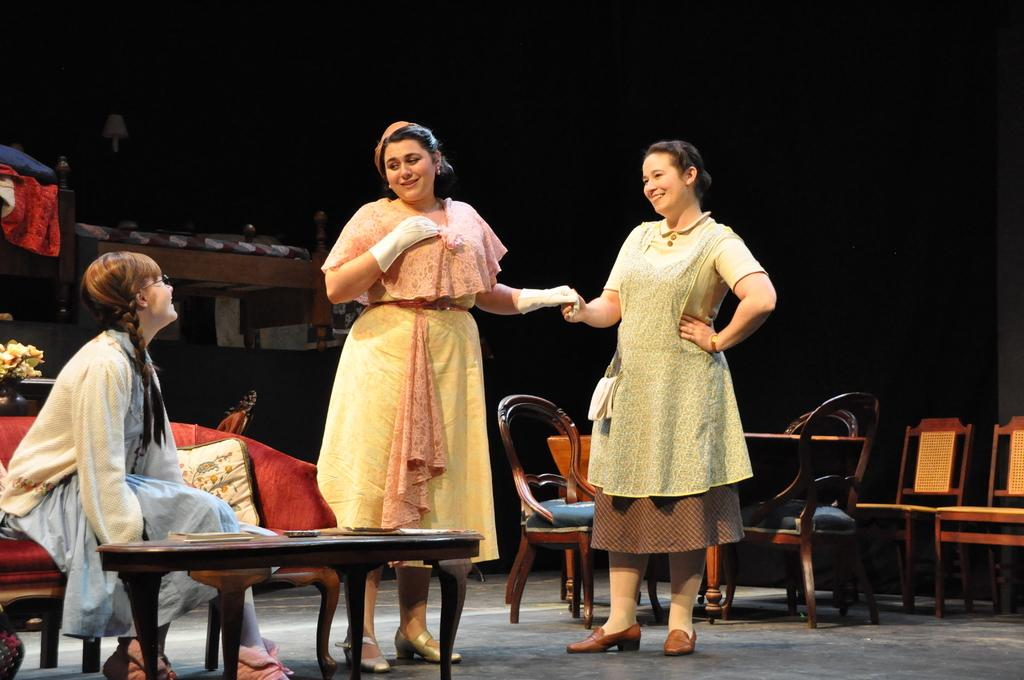What is the person in the image doing? The person is sitting on a sofa in the image. Where is the person located in the image? The person is on the left side of the image. What is happening in front of the person on the sofa? There are two ladies standing in front of the person on the sofa. What type of pot is visible on the holiday in the image? There is no pot or holiday mentioned in the image; it only features a person sitting on a sofa and two ladies standing in front of them. 